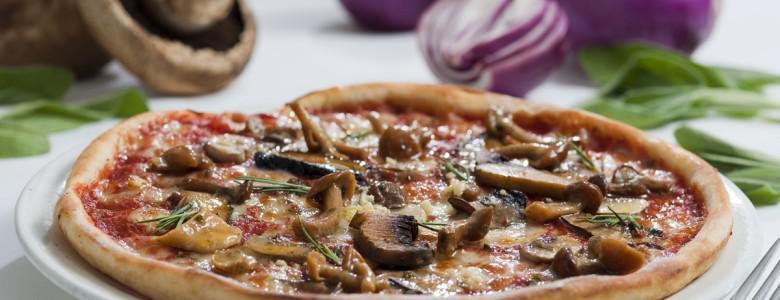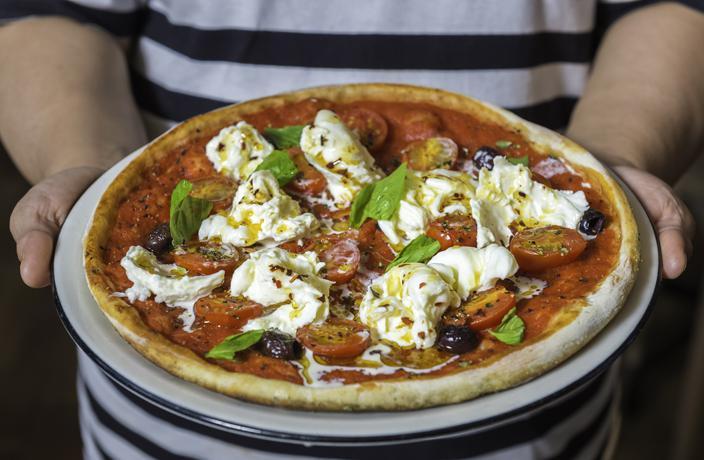The first image is the image on the left, the second image is the image on the right. Assess this claim about the two images: "Two round baked pizzas are on plates, one of them topped with stemmed mushroom pieces.". Correct or not? Answer yes or no. Yes. The first image is the image on the left, the second image is the image on the right. Analyze the images presented: Is the assertion "In at least one image there is a pizza on a white plate with silver edging in front of a white tea cup." valid? Answer yes or no. No. 